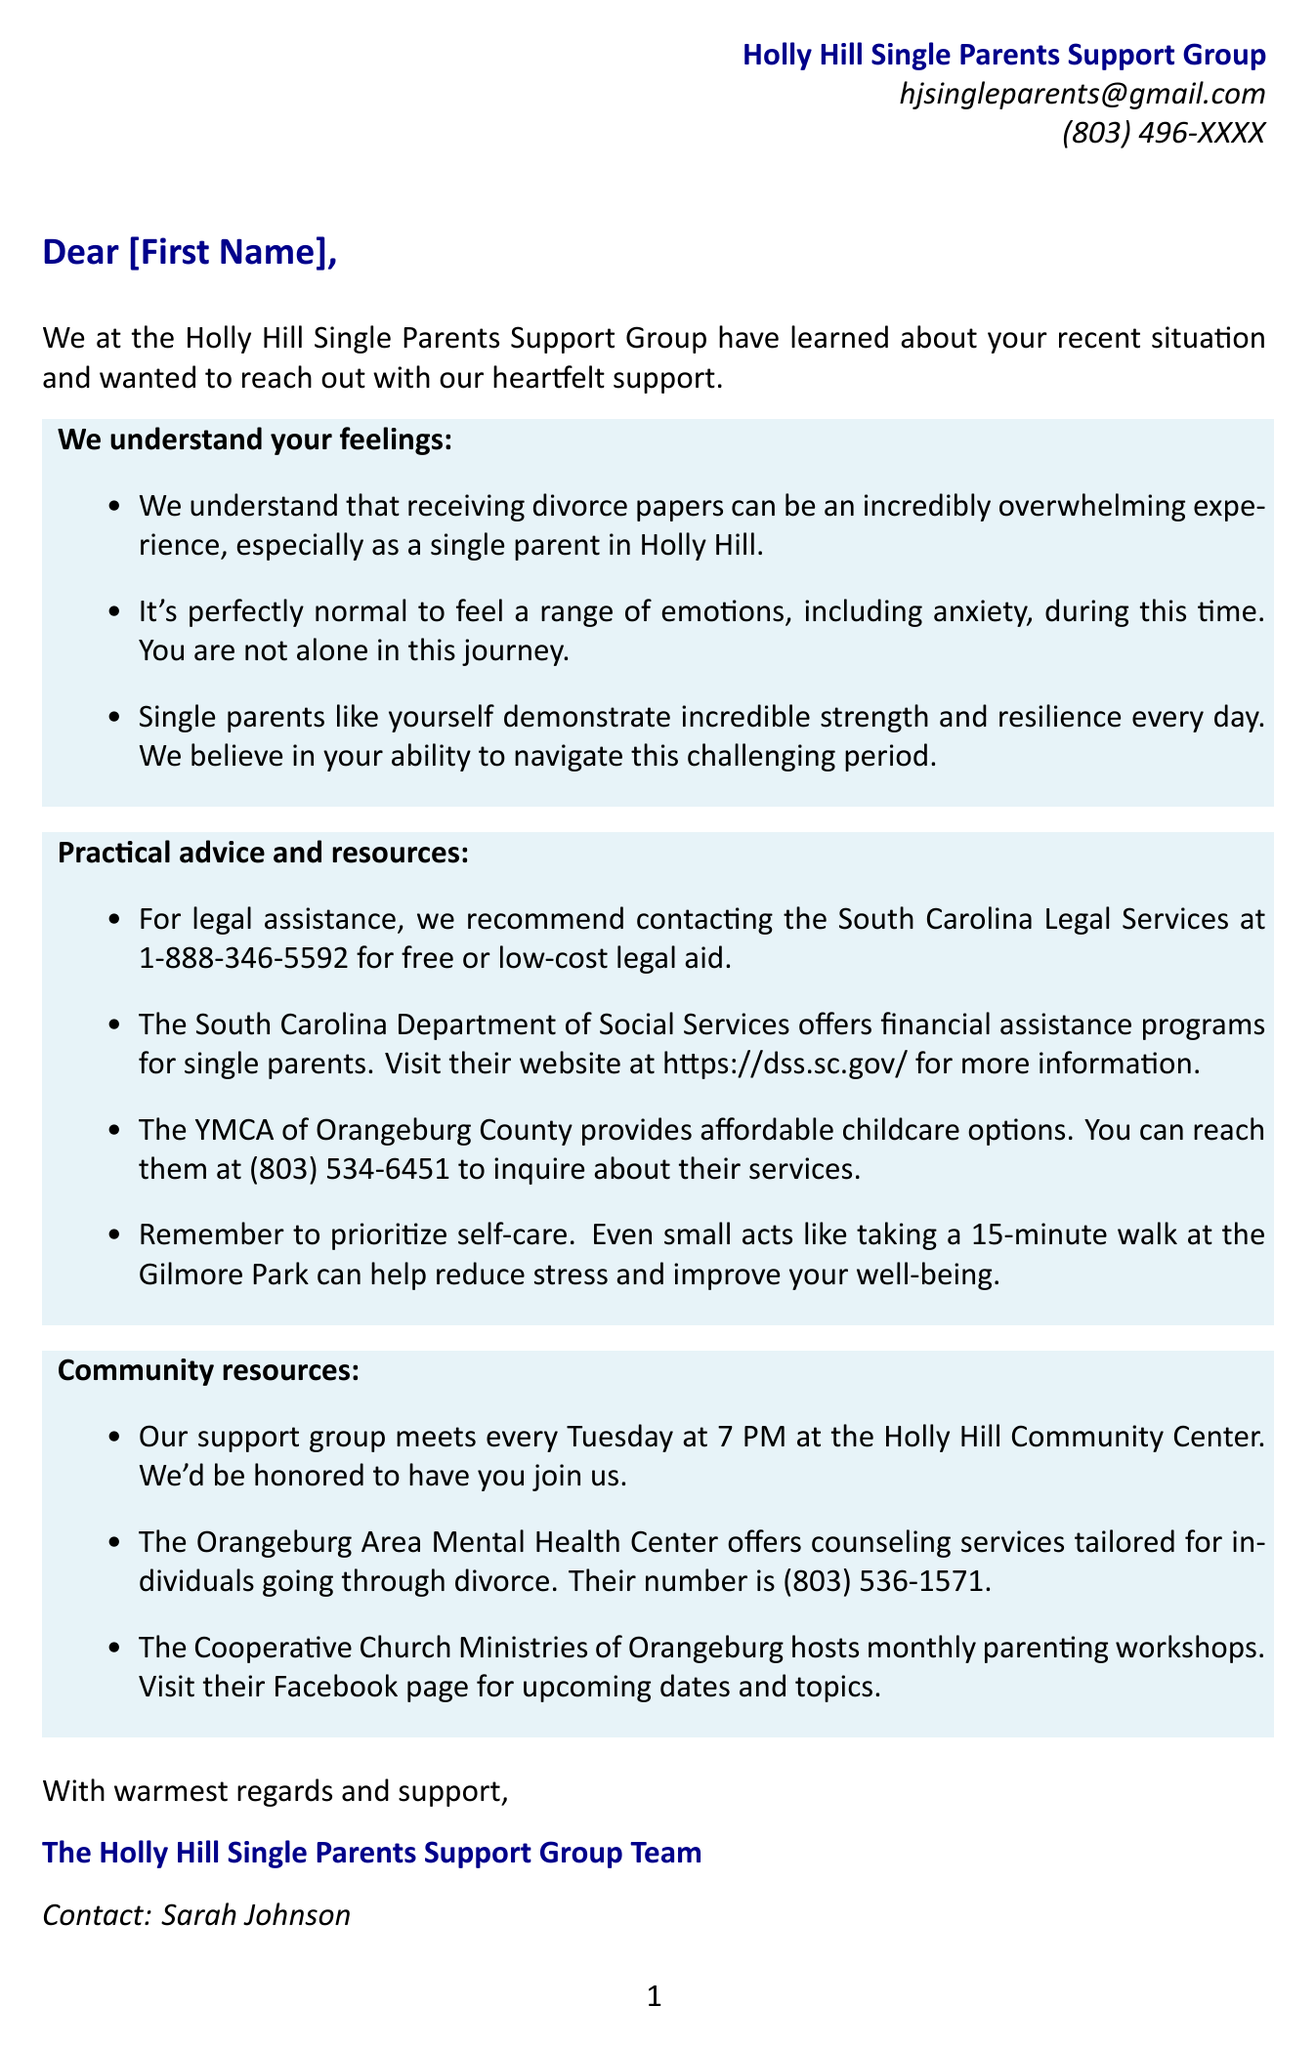What is the name of the support group? The name is mentioned at the beginning of the letter, indicating they are from the Holly Hill Single Parents Support Group.
Answer: Holly Hill Single Parents Support Group Who should be contacted for legal assistance? The document recommends a specific organization for legal aid and provides a contact number.
Answer: South Carolina Legal Services What day does the support group meet? The letter explicitly states the meeting day for the support group.
Answer: Tuesday What time do the support group meetings start? The document specifies the starting time of the support group meetings.
Answer: 7 PM What is one suggested self-care activity? The document includes a specific action that can be taken for self-care.
Answer: Taking a 15-minute walk What type of services does the Orangeburg Area Mental Health Center provide? The letter describes the kind of support offered by this center.
Answer: Counseling services What is the contact email for the support group? The document lists a specific email for contacting the support group.
Answer: hjsingleparents@gmail.com How often are the parenting workshops held? The document mentions the frequency of the workshops hosted by the Cooperative Church Ministries of Orangeburg.
Answer: Monthly What emotional response does the letter acknowledge as normal? The document points out a specific emotional reaction that is considered typical in such situations.
Answer: Anxiety 